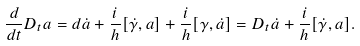Convert formula to latex. <formula><loc_0><loc_0><loc_500><loc_500>\frac { d } { d t } D _ { t } a = d \dot { a } + \frac { i } { h } [ \dot { \gamma } , a ] + \frac { i } { h } [ \gamma , \dot { a } ] = D _ { t } \dot { a } + \frac { i } { h } [ \dot { \gamma } , a ] .</formula> 